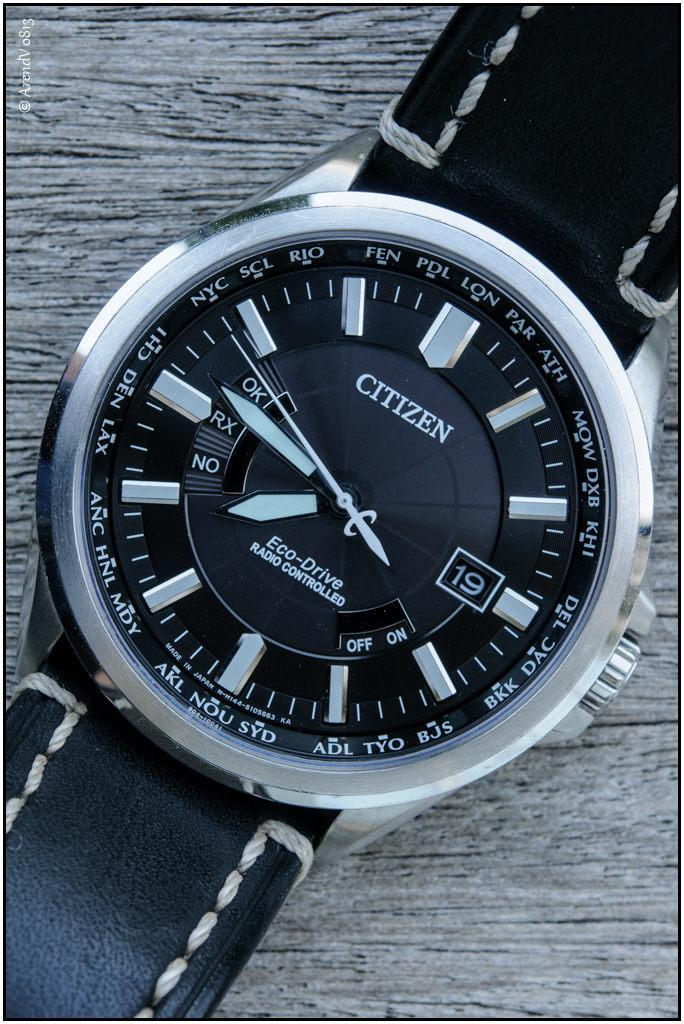<image>
Describe the image concisely. A close up of a Citizen phone with the time at 7:46 